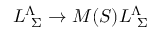<formula> <loc_0><loc_0><loc_500><loc_500>L _ { \ \Sigma } ^ { \Lambda } \to M ( S ) L _ { \ \Sigma } ^ { \Lambda }</formula> 